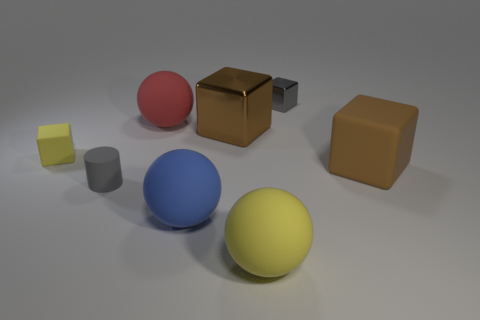There is a object that is right of the gray metal cube; what is its material?
Offer a very short reply. Rubber. There is a matte cube that is to the left of the matte block that is right of the matte ball that is in front of the big blue thing; what is its size?
Provide a short and direct response. Small. Is the size of the gray rubber thing the same as the metallic object that is right of the big shiny cube?
Offer a very short reply. Yes. There is a metal object left of the large yellow matte object; what is its color?
Your response must be concise. Brown. There is a tiny object that is the same color as the tiny cylinder; what shape is it?
Keep it short and to the point. Cube. What shape is the yellow object in front of the small gray matte thing?
Offer a very short reply. Sphere. How many yellow objects are either shiny things or big matte things?
Your response must be concise. 1. Do the tiny gray cylinder and the big yellow ball have the same material?
Ensure brevity in your answer.  Yes. There is a big brown shiny object; how many tiny gray cubes are to the right of it?
Make the answer very short. 1. There is a small object that is both to the right of the tiny yellow rubber object and behind the big matte block; what material is it made of?
Keep it short and to the point. Metal. 